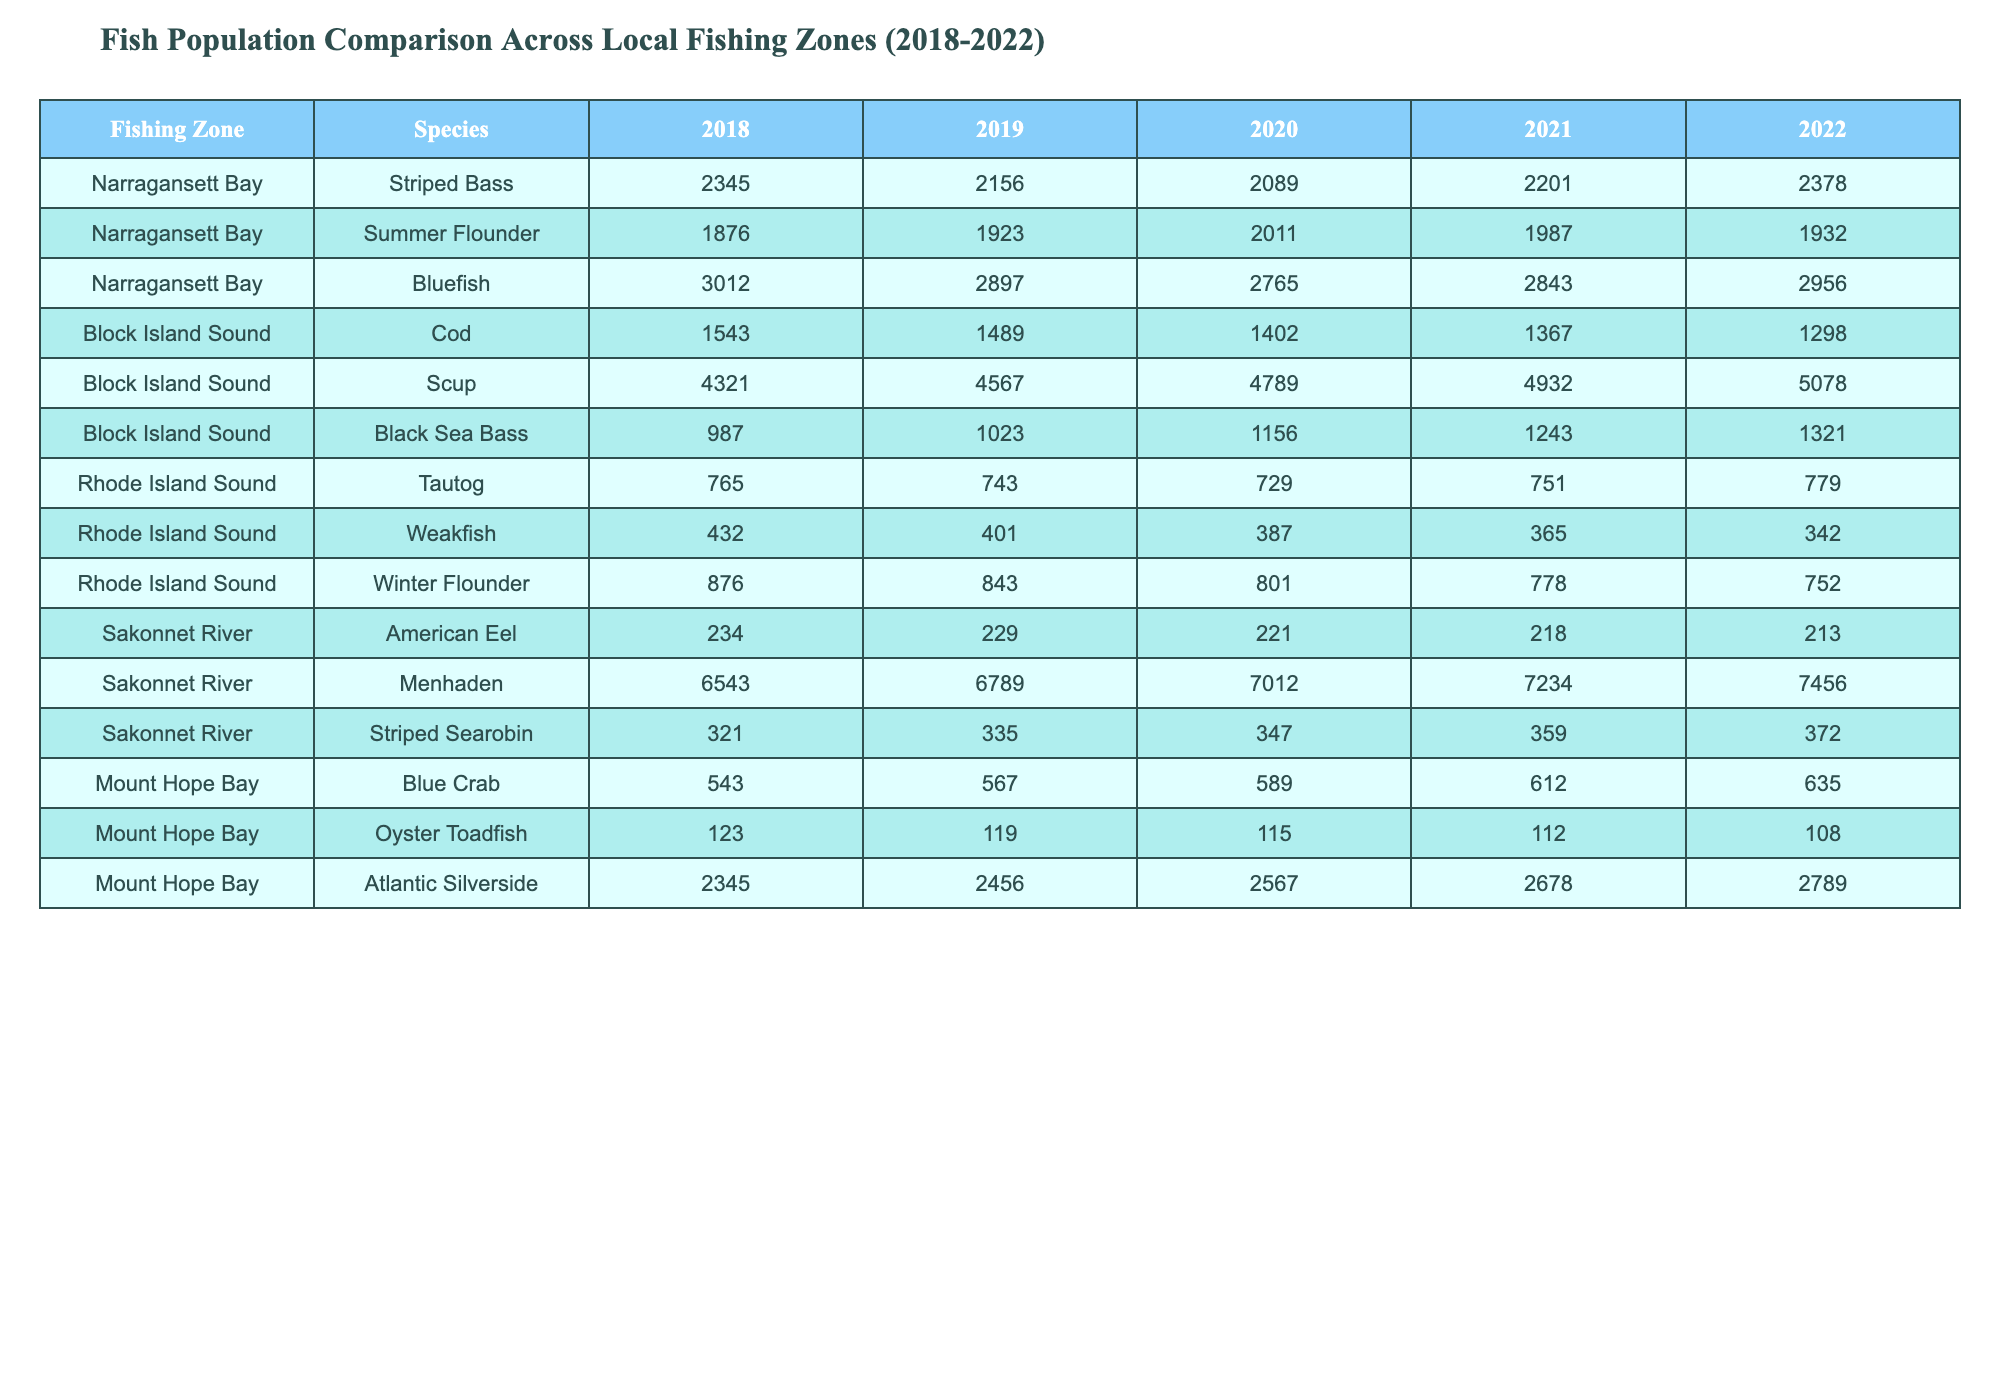What was the population of Striped Bass in Narragansett Bay in 2022? In the table, I locate the row for Narragansett Bay under the Species column where Striped Bass is listed. The corresponding value for 2022 is 2378.
Answer: 2378 Which species had the highest population in Block Island Sound in 2021? I check the Block Island Sound section, looking at the populations for all species in 2021. The highest value among Cod (1367), Scup (4932), and Black Sea Bass (1243) is 4932 for Scup.
Answer: Scup What is the average population of Weakfish from 2018 to 2022? I find the values for Weakfish for each year: 432 (2018), 401 (2019), 387 (2020), 365 (2021), and 342 (2022). Adding these gives 432 + 401 + 387 + 365 + 342 = 1927. Dividing by 5 (years) results in an average of 1927 / 5 = 385.4.
Answer: 385.4 Did the population of Bluefish in Narragansett Bay increase every year from 2018 to 2022? I look at the values for Bluefish: 3012 (2018), 2897 (2019), 2765 (2020), 2843 (2021), and 2956 (2022). The population decreased from 2018 to 2019, then decreased again in 2020 before rising in the last two years, indicating it did not increase every year.
Answer: No In which year did the population of Menhaden in Sakonnet River increase the most from the previous year? I check the values for Menhaden: 6543 (2018), 6789 (2019), 7012 (2020), 7234 (2021), and 7456 (2022). The annual increases are 246 (2018-2019), 223 (2019-2020), 222 (2020-2021), and 222 (2021-2022). The largest increase occurred in 2018 to 2019.
Answer: 2019 What are the total populations of fish species in Mount Hope Bay in 2022? I find the populations for each species in Mount Hope Bay for 2022: Blue Crab (635), Oyster Toadfish (108), and Atlantic Silverside (2789). Adding these values gives 635 + 108 + 2789 = 3532.
Answer: 3532 Which fishing zone had the lowest total fish population across all species in 2019? I calculate the total populations across all species for each zone in 2019: Narragansett Bay (2156 + 1923 + 2897 = 6976), Block Island Sound (1489 + 4567 + 1023 = 7079), Rhode Island Sound (743 + 401 + 843 = 1987), Sakonnet River (229 + 6789 + 335 = 7353), and Mount Hope Bay (567 + 119 + 2456 = 3142). Rhode Island Sound has the lowest total of 1987.
Answer: Rhode Island Sound What was the trend in the population of Atlantic Silverside in Mount Hope Bay from 2018 to 2022? I look at the values: 2345 (2018), 2456 (2019), 2567 (2020), 2678 (2021), and 2789 (2022). The population consistently increased each year.
Answer: Consistently increased How much did the population of Cod in Block Island Sound decrease from 2018 to 2022? I find the values: 1543 (2018) and 1298 (2022). The decrease is 1543 - 1298 = 245.
Answer: 245 